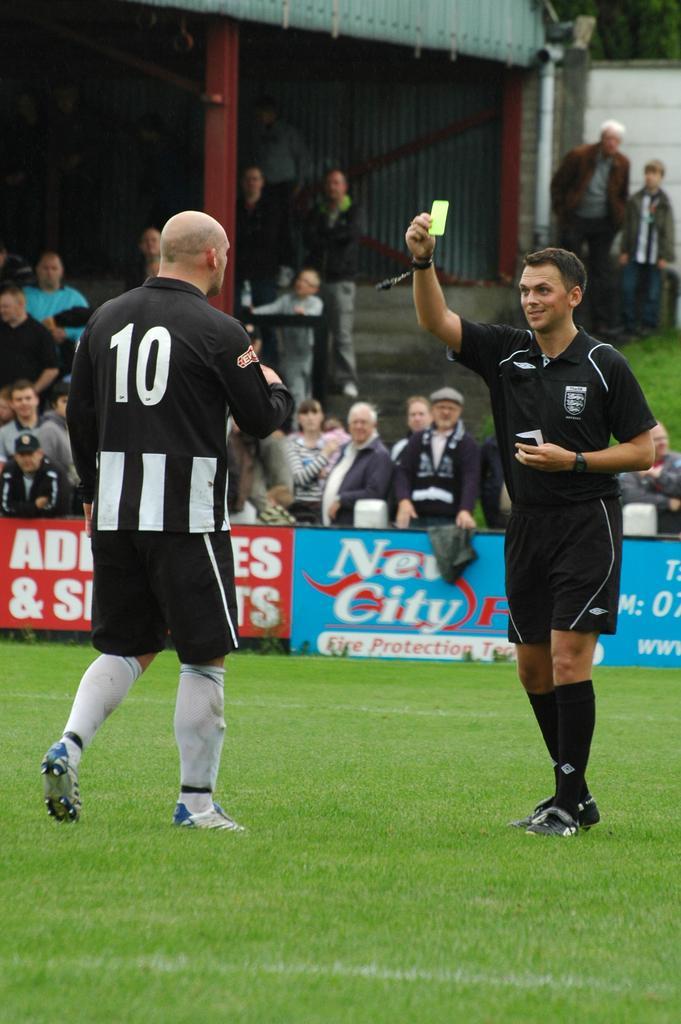Describe this image in one or two sentences. In this image we can see one send, one pipe attached to the shed, one wall, some trees behind the wall, some grass on the ground, one object on the table, two men walking on the ground, some people are standing, some people are holding objects, one coat on the board, one board with text on the ground, one woman holding a baby, one white object behind the board, one man holding an object and the background is dark. 